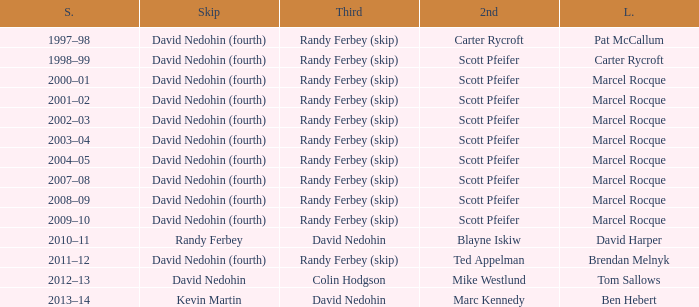Which Lead has a Third of randy ferbey (skip), a Second of scott pfeifer, and a Season of 2009–10? Marcel Rocque. 